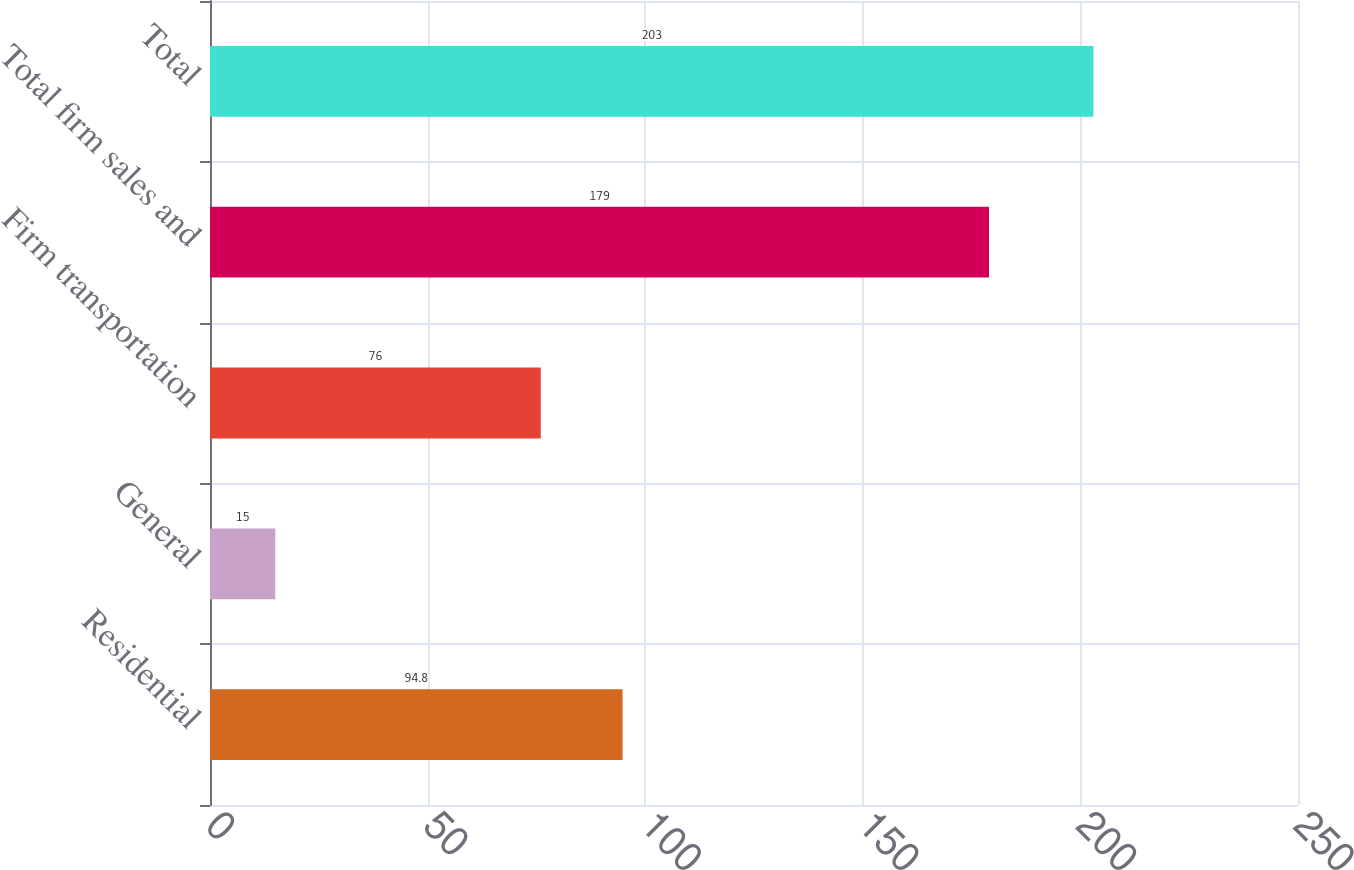Convert chart to OTSL. <chart><loc_0><loc_0><loc_500><loc_500><bar_chart><fcel>Residential<fcel>General<fcel>Firm transportation<fcel>Total firm sales and<fcel>Total<nl><fcel>94.8<fcel>15<fcel>76<fcel>179<fcel>203<nl></chart> 